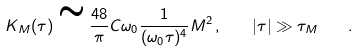<formula> <loc_0><loc_0><loc_500><loc_500>K _ { M } ( \tau ) \cong \frac { 4 8 } { \pi } C \omega _ { 0 } \frac { 1 } { ( \omega _ { 0 } \tau ) ^ { 4 } } M ^ { 2 } \, , \quad | \tau | \gg \tau _ { M } \quad .</formula> 